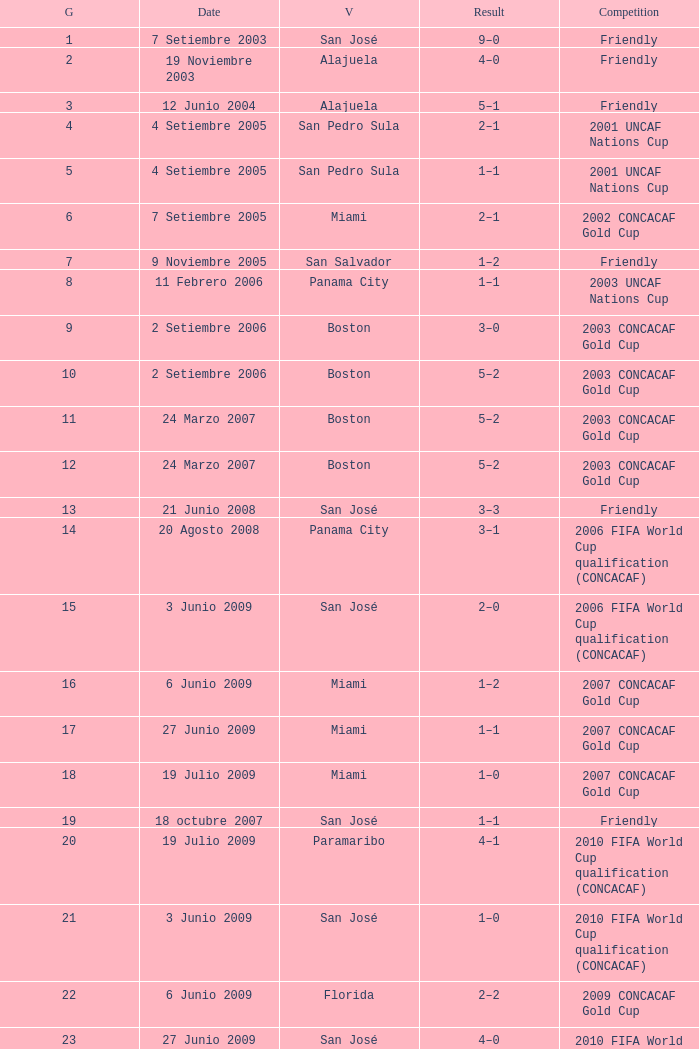At the venue of panama city, on 11 Febrero 2006, how many goals were scored? 1.0. 